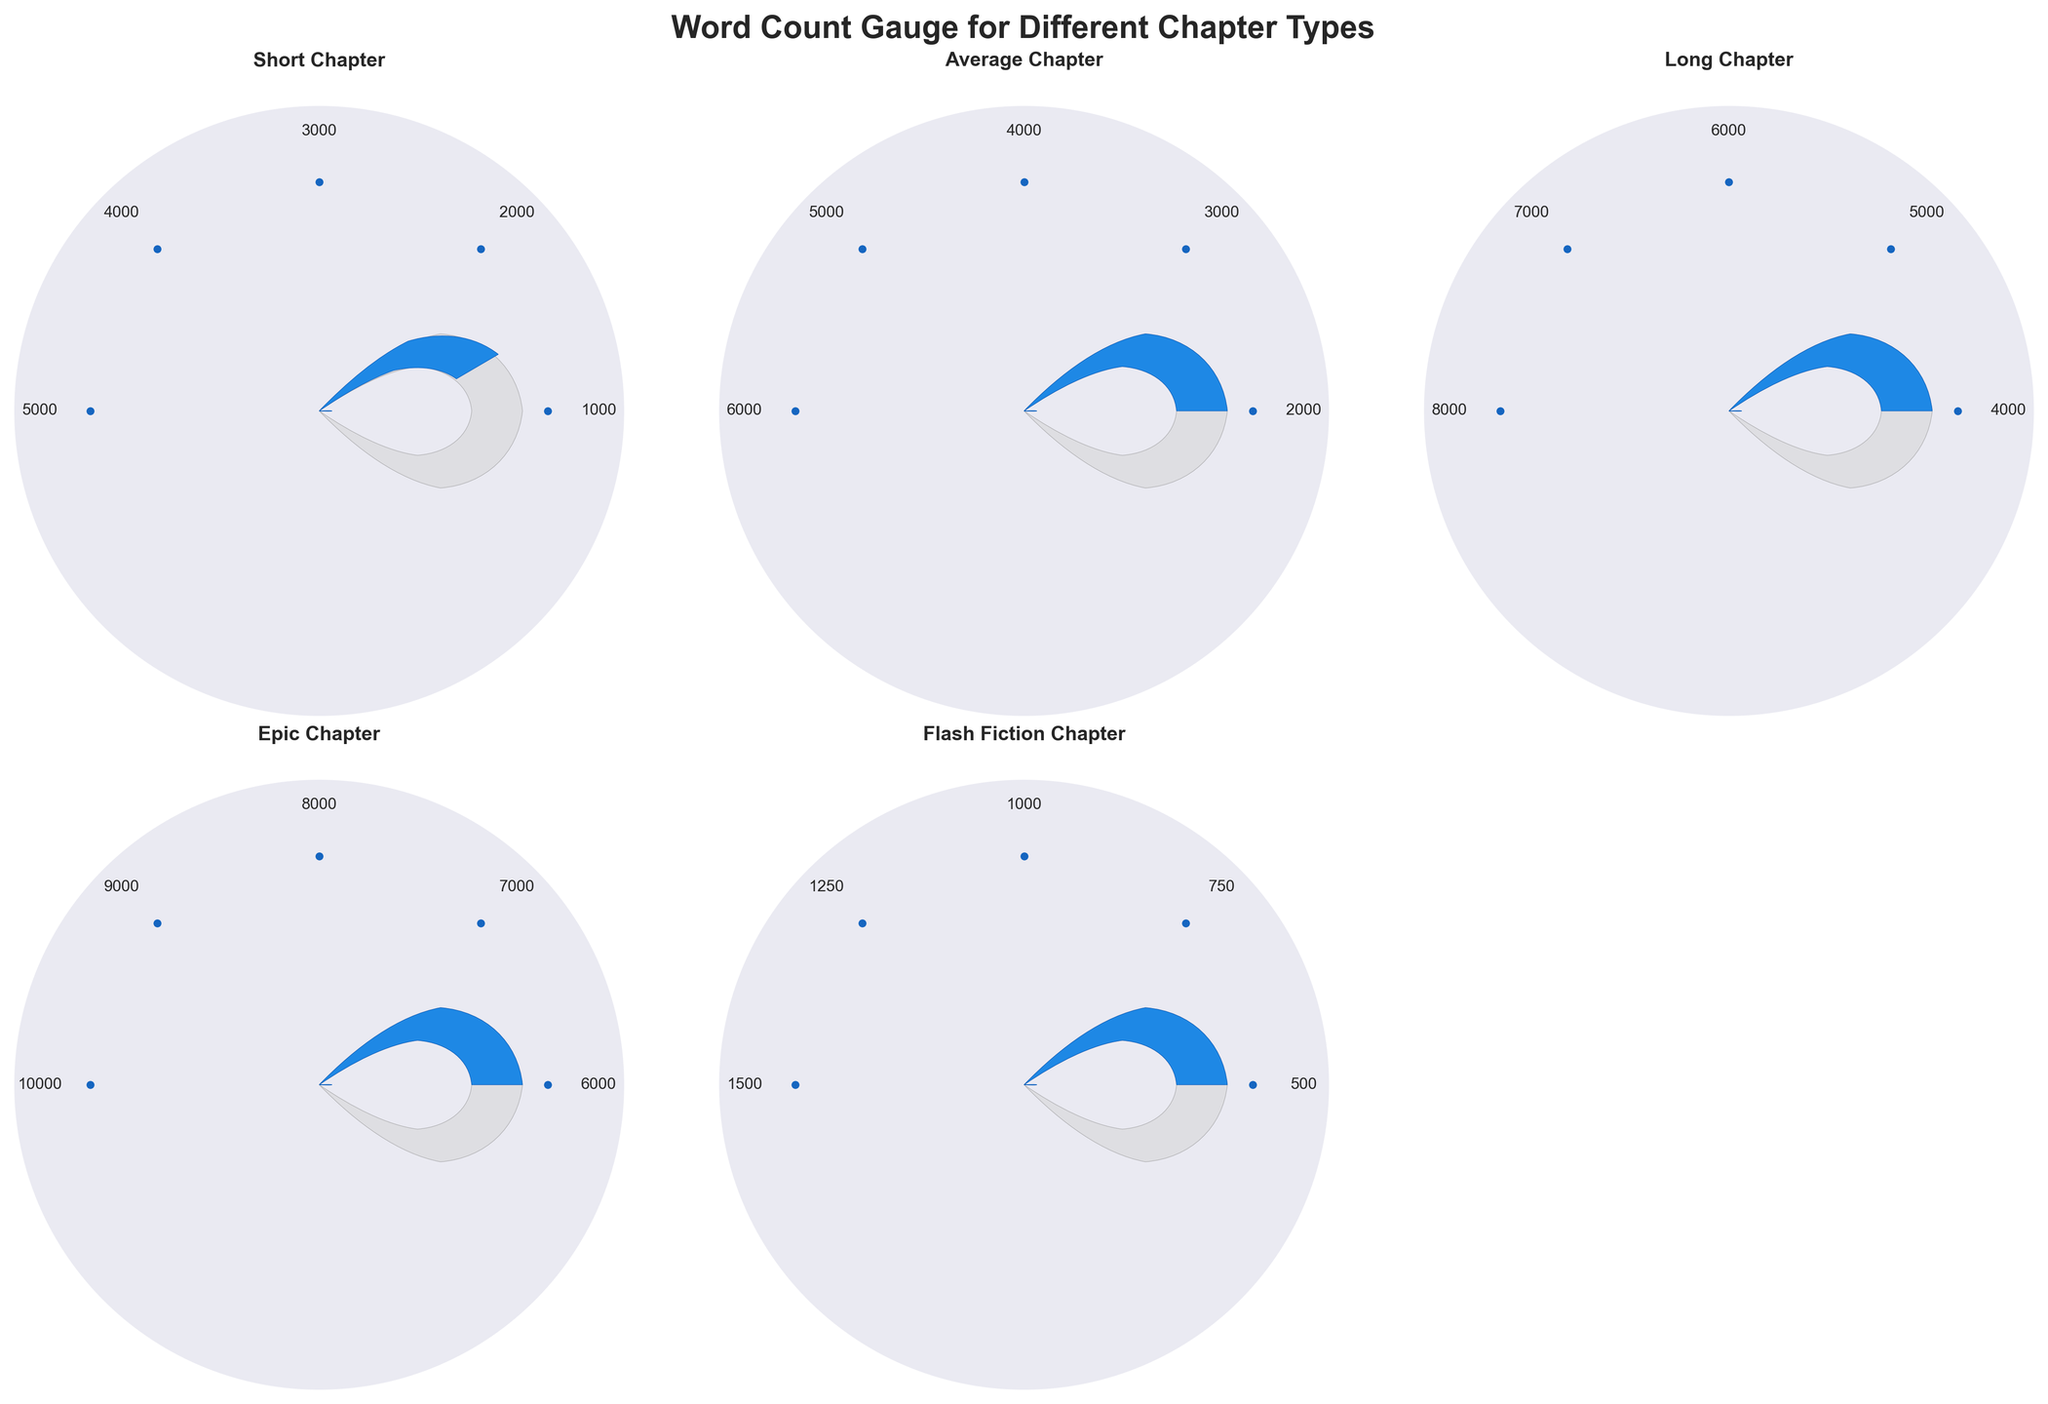What's the title of the figure? The title is shown at the top of the figure in bold text. It reads, "Word Count Gauge for Different Chapter Types".
Answer: Word Count Gauge for Different Chapter Types How many chapter types are displayed in the figure? There is one gauge chart for each chapter type. Looking at the figure, there are five charts corresponding to each chapter type listed.
Answer: Five What is the word count for the 'Epic Chapter'? The word count is displayed in the center below each gauge. For the 'Epic Chapter', it reads 8000.
Answer: 8000 Which chapter type has the highest word count? By comparing the word counts shown in each gauge chart, the 'Epic Chapter' has the highest word count of 8000.
Answer: Epic Chapter What is the range of word counts for the 'Average Chapter'? The range is defined by the minimum and maximum values displayed around the gauge. For the 'Average Chapter', it ranges from 2000 to 6000.
Answer: 2000 to 6000 How does the 'Flash Fiction Chapter' word count compare to the 'Long Chapter' word count? The 'Flash Fiction Chapter' has a word count of 1000, while the 'Long Chapter' has 6000. Comparing these, the 'Flash Fiction Chapter' has significantly fewer words.
Answer: 'Flash Fiction Chapter' has fewer words What percentage of the 'Short Chapter' word count is from its max value? The 'Short Chapter' word count is 2500, and the max value is 5000. The percentage is (2500/5000) * 100 = 50%.
Answer: 50% Which chapter type has a word count close to the midpoint of its range? Calculate the midpoint for each chapter type's range, and compare it to the word count. The midpoint for the 'Long Chapter' is (4000+8000)/2 = 6000, which matches its word count.
Answer: Long Chapter What is the difference in word count between 'Short Chapter' and 'Long Chapter'? The word count of 'Long Chapter' is 6000 and 'Short Chapter' is 2500. The difference is 6000 - 2500 = 3500.
Answer: 3500 Is the 'Flash Fiction Chapter' word count within the first quartile of its range? The first quartile of the range is (Min + 0.25*(Max - Min)). For 'Flash Fiction Chapter', it’s (500 + 0.25*(1500 - 500)) = 750. Since the word count is 1000, it is not in the first quartile.
Answer: No 